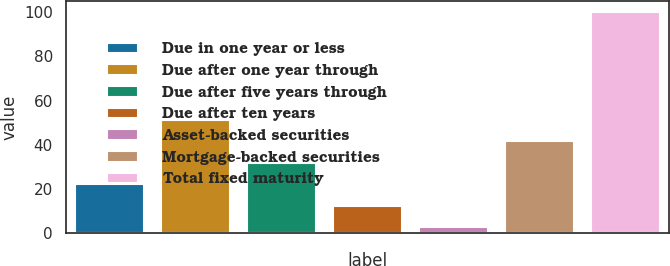<chart> <loc_0><loc_0><loc_500><loc_500><bar_chart><fcel>Due in one year or less<fcel>Due after one year through<fcel>Due after five years through<fcel>Due after ten years<fcel>Asset-backed securities<fcel>Mortgage-backed securities<fcel>Total fixed maturity<nl><fcel>22.08<fcel>51.3<fcel>31.82<fcel>12.34<fcel>2.6<fcel>41.56<fcel>100<nl></chart> 